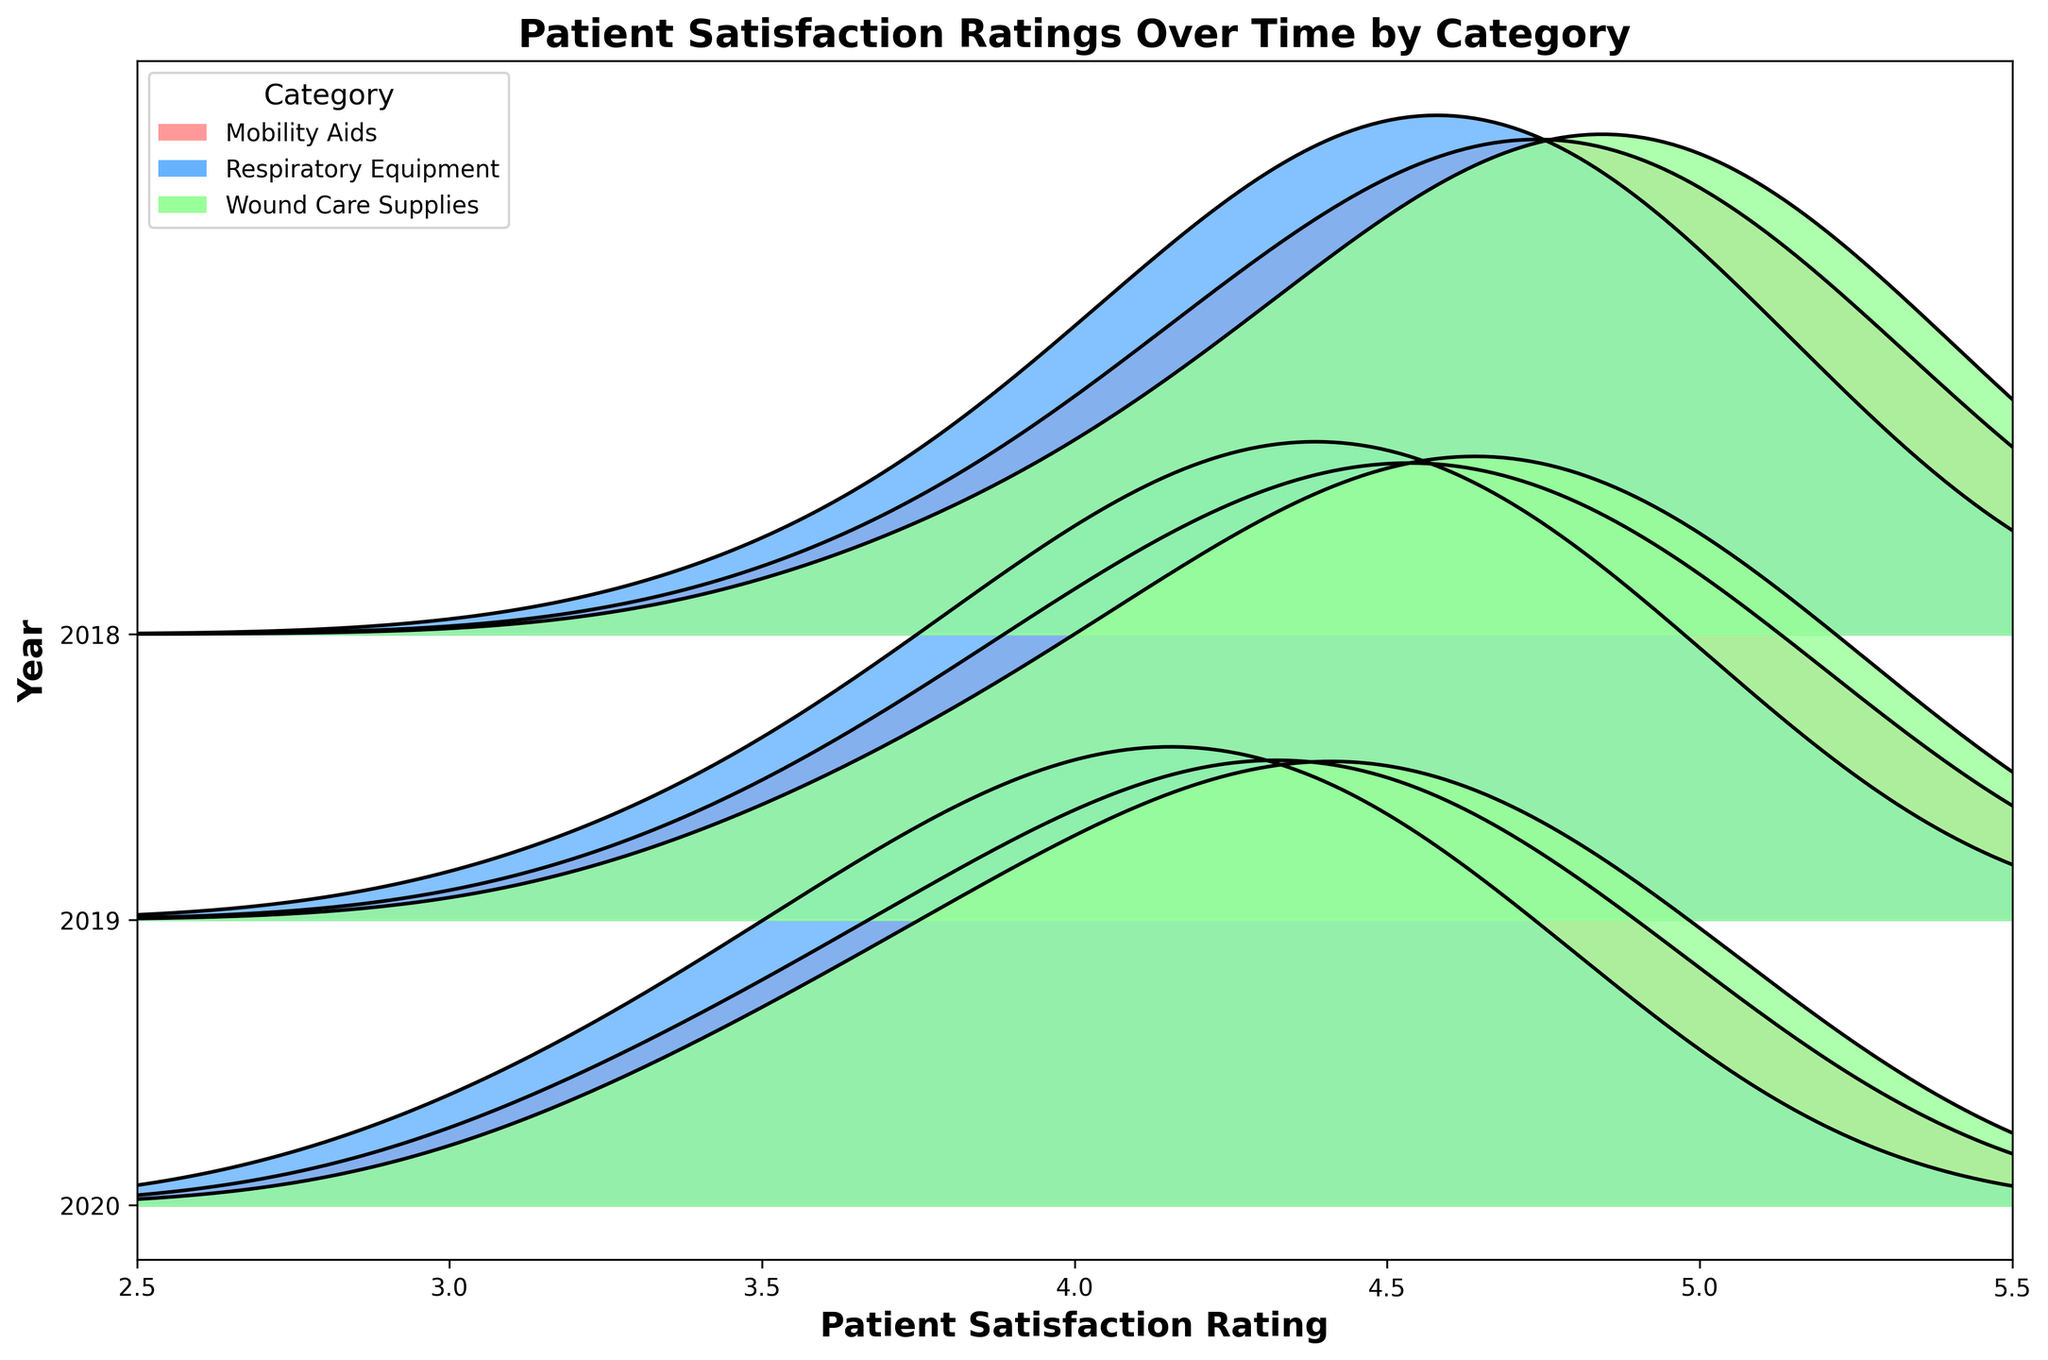What is the title of the plot? The title of the plot is written at the top center.
Answer: Patient Satisfaction Ratings Over Time by Category How many categories of medical supplies are represented in the plot? The legend on the top left indicates the number of categories shown in the plot.
Answer: Three What are the years depicted in the plot? The y-axis labels on the left-hand side show the years.
Answer: 2018, 2019, 2020 Does the plot show that patient satisfaction ratings for Mobility Aids improved over time? By comparing the density peaks of Mobility Aids across the years 2018, 2019, and 2020, we can observe if the peaks shift towards higher ratings.
Answer: Yes Which category had the highest density of ratings around 5.0 in 2020? By observing the curves for each category in 2020, we can identify which category's curve peaks closest to 5.0.
Answer: Wound Care Supplies How does the patient satisfaction rating for Respiratory Equipment in 2018 compare to 2020? Compare the density curves of Respiratory Equipment for the years 2018 and 2020. Note how the peaks shift between the years.
Answer: It increased Which category shows the largest spread in ratings in 2020? By looking at the width of the densest part of each category's curve in 2020, we can judge which has the largest spread.
Answer: Wound Care Supplies Between which ranges do the patient satisfaction ratings for Wound Care Supplies fall in 2018? Inspect the Wound Care Supplies curve for 2018 and note the range where the density is observed.
Answer: 3.3 to 5.1 What is the densest patient satisfaction rating value for Mobility Aids in 2019? Find the peak of the Mobility Aids curve in 2019, which indicates the densest rating value.
Answer: 4.6 For which category and year do we observe the highest overall density value in the plot? Identify the peak density value and then find the corresponding category and year.
Answer: Respiratory Equipment in 2020 